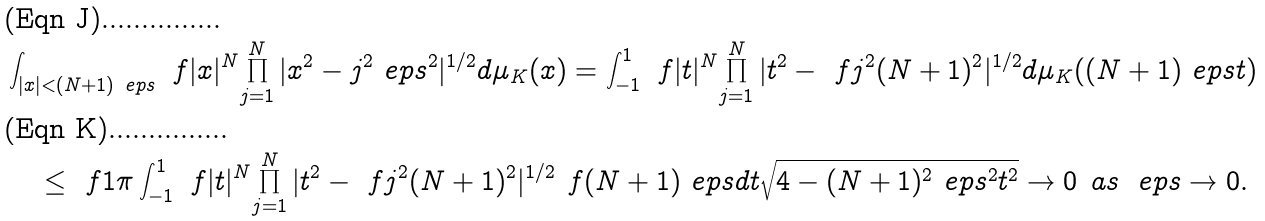<formula> <loc_0><loc_0><loc_500><loc_500>& \int _ { | x | < ( N + 1 ) \ e p s } \ f { | x | ^ { N } } { \prod _ { j = 1 } ^ { N } | x ^ { 2 } - j ^ { 2 } \ e p s ^ { 2 } | ^ { 1 / 2 } } d \mu _ { K } ( x ) = \int _ { - 1 } ^ { 1 } \ f { | t | ^ { N } } { \prod _ { j = 1 } ^ { N } | t ^ { 2 } - \ f { j ^ { 2 } } { ( N + 1 ) ^ { 2 } } | ^ { 1 / 2 } } d \mu _ { K } ( ( N + 1 ) \ e p s t ) \\ & \quad \leq \ f 1 \pi \int _ { - 1 } ^ { 1 } \ f { | t | ^ { N } } { \prod _ { j = 1 } ^ { N } | t ^ { 2 } - \ f { j ^ { 2 } } { ( N + 1 ) ^ { 2 } } | ^ { 1 / 2 } } \ f { ( N + 1 ) \ e p s d t } { \sqrt { 4 - ( N + 1 ) ^ { 2 } \ e p s ^ { 2 } t ^ { 2 } } } \to 0 \text { as } \ e p s \to 0 .</formula> 